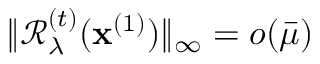Convert formula to latex. <formula><loc_0><loc_0><loc_500><loc_500>\| \mathcal { R } _ { \lambda } ^ { ( t ) } ( x ^ { ( 1 ) } ) \| _ { \infty } = o ( \bar { \mu } )</formula> 